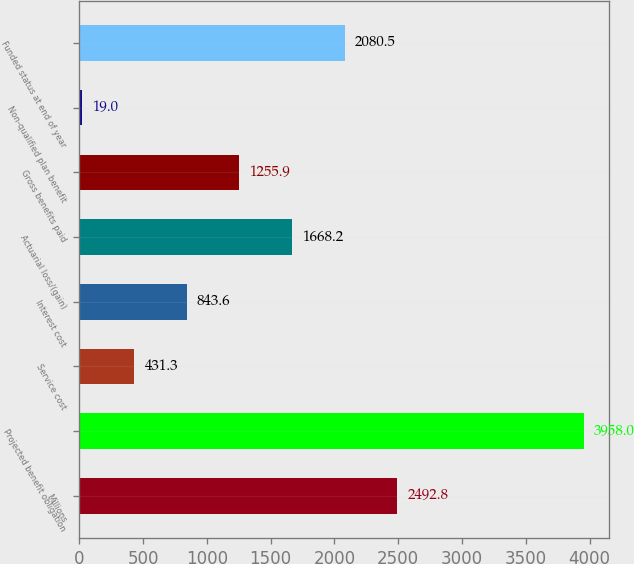Convert chart. <chart><loc_0><loc_0><loc_500><loc_500><bar_chart><fcel>Millions<fcel>Projected benefit obligation<fcel>Service cost<fcel>Interest cost<fcel>Actuarial loss/(gain)<fcel>Gross benefits paid<fcel>Non-qualified plan benefit<fcel>Funded status at end of year<nl><fcel>2492.8<fcel>3958<fcel>431.3<fcel>843.6<fcel>1668.2<fcel>1255.9<fcel>19<fcel>2080.5<nl></chart> 